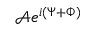Convert formula to latex. <formula><loc_0><loc_0><loc_500><loc_500>\mathcal { A } e ^ { i ( \Psi + \Phi ) }</formula> 